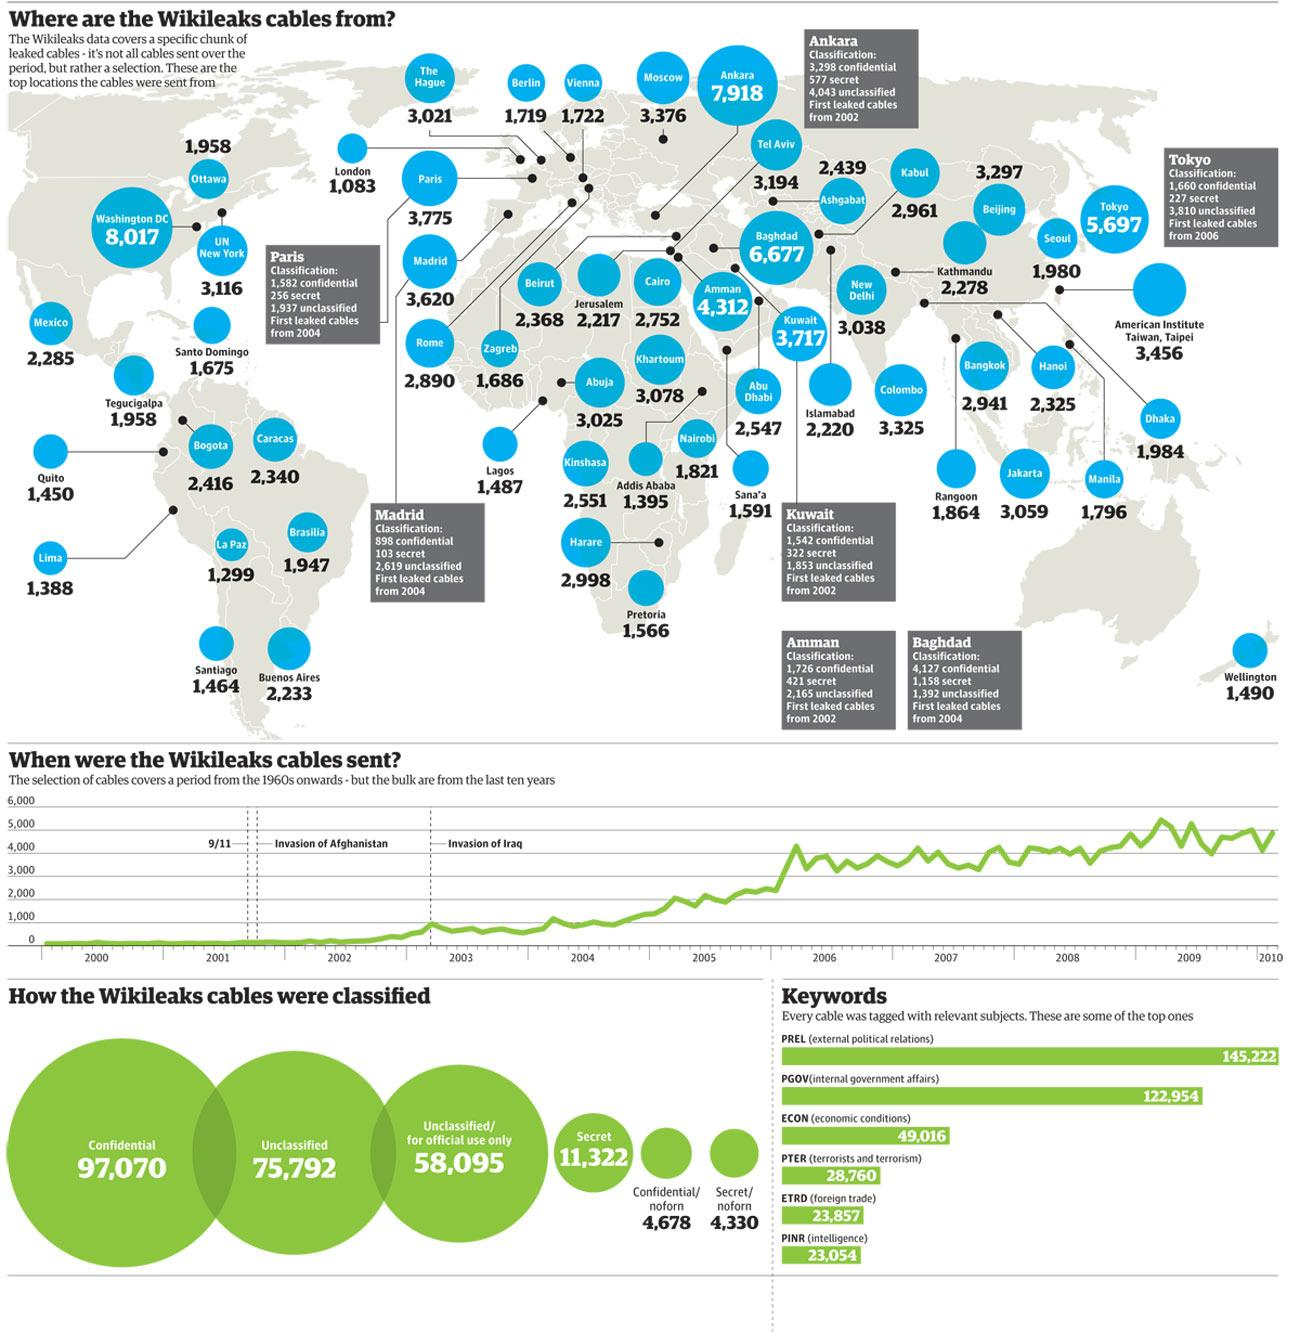Draw attention to some important aspects in this diagram. In total, 122,954 leaked cables were tagged with the category "PGOV(internal government affairs)". In total, 97,070 Wikileaks cables were classified as confidential. The state of Washington, D.C. has the highest number of Wikileaks cables. There were 4,127 confidential classified cables leaked in Baghdad. There have been 2,890 leaked cables originating from Rome. 